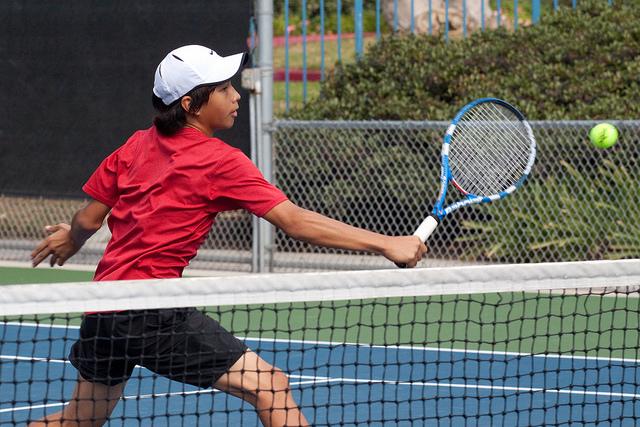What is the boy holding?
Write a very short answer. Tennis racket. Is this an adult?
Be succinct. No. What level of play is being witnessed?
Answer briefly. Junior. 